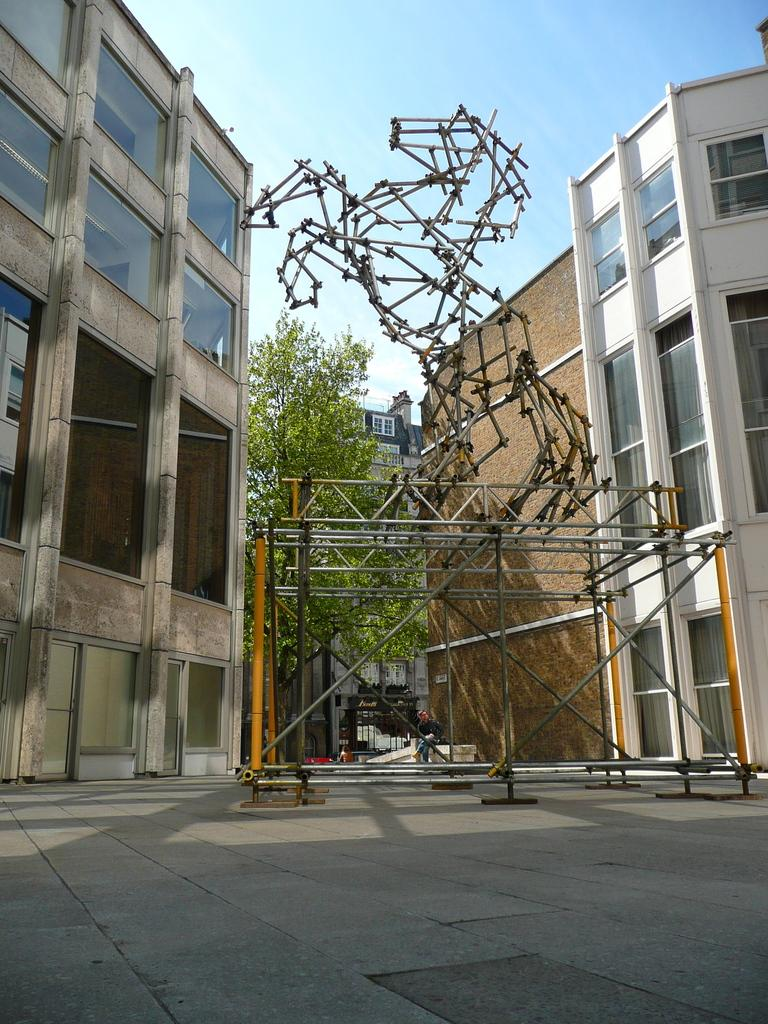What is the main feature of the image? There is a road in the image. What else can be seen in the image besides the road? There is a tree, buildings with windows, rods, a person sitting on a platform, and objects in the image. Can you describe the buildings in the image? The buildings have windows. What is the person sitting on in the image? The person is sitting on a platform. What is visible in the background of the image? The sky is visible in the background of the image. How does the squirrel start running on the road in the image? There is no squirrel present in the image, so it cannot start running on the road. 